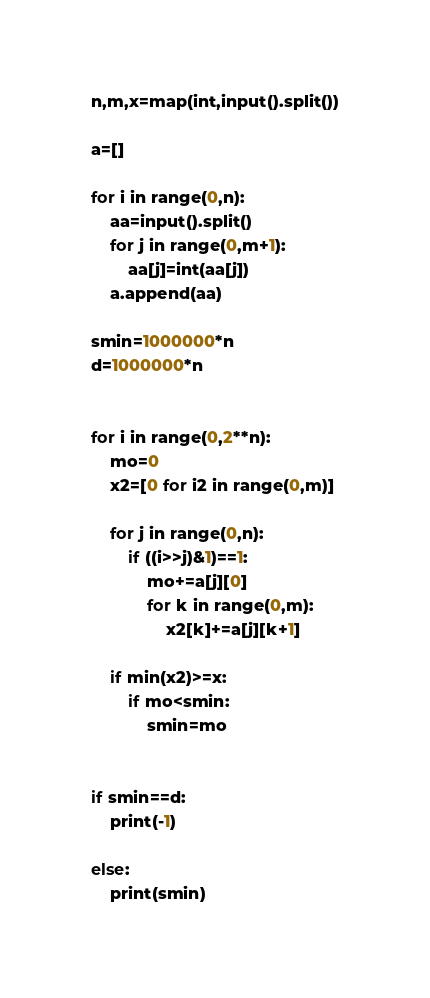<code> <loc_0><loc_0><loc_500><loc_500><_Python_>n,m,x=map(int,input().split())

a=[]

for i in range(0,n):
    aa=input().split()
    for j in range(0,m+1):
        aa[j]=int(aa[j])
    a.append(aa)

smin=1000000*n
d=1000000*n


for i in range(0,2**n):
    mo=0
    x2=[0 for i2 in range(0,m)]
    
    for j in range(0,n):
        if ((i>>j)&1)==1:
            mo+=a[j][0]
            for k in range(0,m):
                x2[k]+=a[j][k+1]

    if min(x2)>=x:
        if mo<smin:
            smin=mo
    

if smin==d:
    print(-1)

else:
    print(smin)</code> 